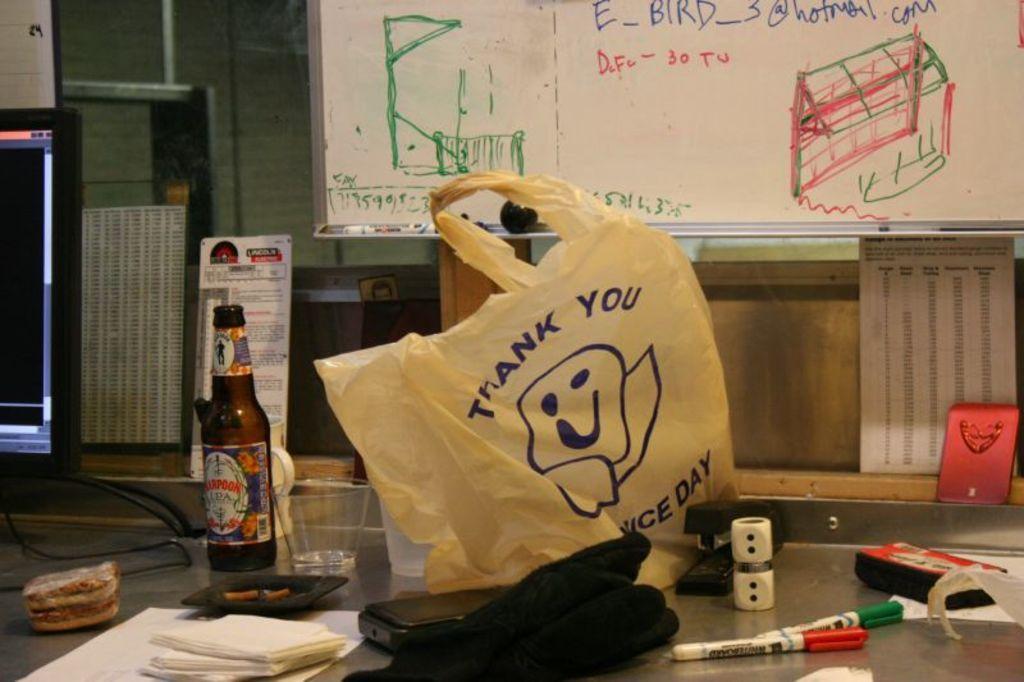Could you give a brief overview of what you see in this image? In this picture we can see a bottle, glass, tissues, markers, and a cover on the floor. This is board. On the background there is a wall. And this is the screen. 